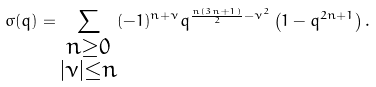Convert formula to latex. <formula><loc_0><loc_0><loc_500><loc_500>\sigma ( q ) = \sum _ { \substack { n \geq 0 \\ | \nu | \leq n } } ( - 1 ) ^ { n + \nu } q ^ { \frac { n ( 3 n + 1 ) } 2 - \nu ^ { 2 } } \left ( 1 - q ^ { 2 n + 1 } \right ) .</formula> 